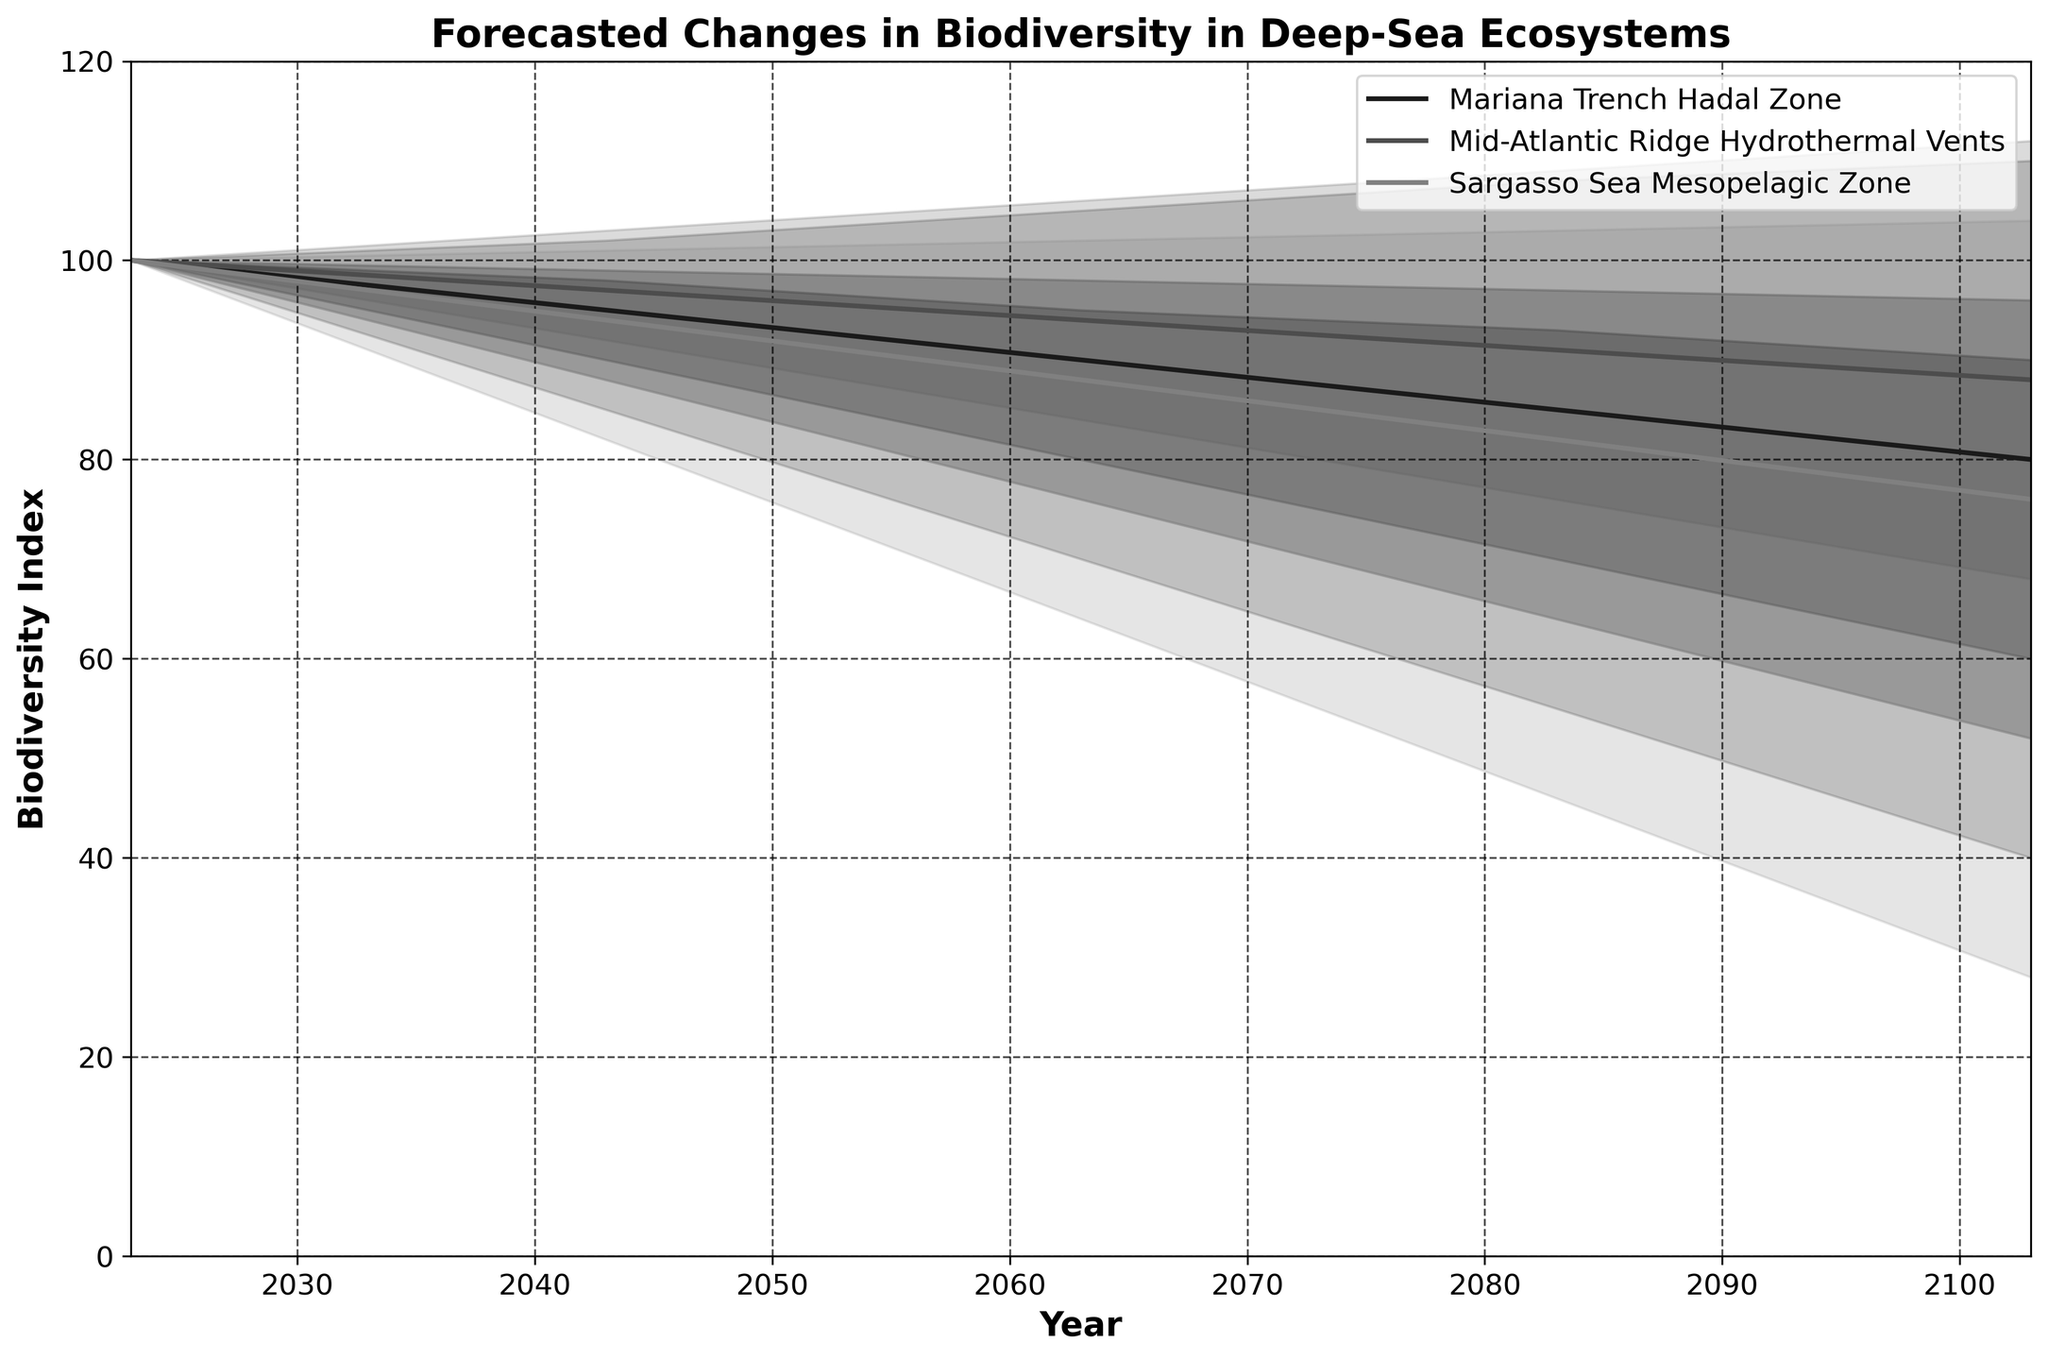what is the title of the chart? The title of the chart is typically located at the top center of the figure. In this case, it states the subject and scope of the plot, which is 'Forecasted Changes in Biodiversity in Deep-Sea Ecosystems'.
Answer: Forecasted Changes in Biodiversity in Deep-Sea Ecosystems What is the range of years covered in the chart? The x-axis typically represents the time span in the chart. Here, it ranges from 2023 to 2103.
Answer: 2023 to 2103 What ecosystem shows the highest uncertainty in biodiversity predictions for 2103? Uncertainty can be gauged by the width of the shaded area (band between the low and high forecasts). In 2103, Mid-Atlantic Ridge Hydrothermal Vents has the widest band from 52 to 112.
Answer: Mid-Atlantic Ridge Hydrothermal Vents Which ecosystem has the steepest decline in the central tendency (Mid) values over the forecast period? Looking at the Mid line for each ecosystem, the Sargasso Sea Mesopelagic Zone shows the steepest decline from 100 in 2023 to 76 in 2103.
Answer: Sargasso Sea Mesopelagic Zone How does the biodiversity of the Mariana Trench Hadal Zone in 2063 compare to its biodiversity in 2043? Looking at the Mid value in 2043 and 2063 for this ecosystem, it declines from 95 to 90.
Answer: It decreases from 95 to 90 What is the difference between the highest and lowest biodiversity predictions for the Sargasso Sea Mesopelagic Zone in 2083? The difference is calculated by subtracting the lowest value (46) from the highest value (103).
Answer: 57 What is the average of the Mid-High value for the Mid-Atlantic Ridge Hydrothermal Vents from 2023 to 2043? The Mid-High values for these years are 100 and 99. The average is calculated as (100 + 99) / 2.
Answer: 99.5 How does the Mid biodiversity index of the Mariana Trench Hadal Zone in 2103 compare to the Mid-Atlantic Ridge Hydrothermal Vents in the same year? The Mid index for Mariana Trench Hadal Zone in 2103 is 80, and for Mid-Atlantic Ridge Hydrothermal Vents, it is 88.
Answer: Mariana Trench Hadal Zone is 8 units lower Which ecosystem's biodiversity index shows the most variability throughout the forecast period? Variability can be assessed by the overall difference between the high and low values throughout the period. The Mid-Atlantic Ridge Hydrothermal Vents shows the highest range of values from high to low.
Answer: Mid-Atlantic Ridge Hydrothermal Vents 